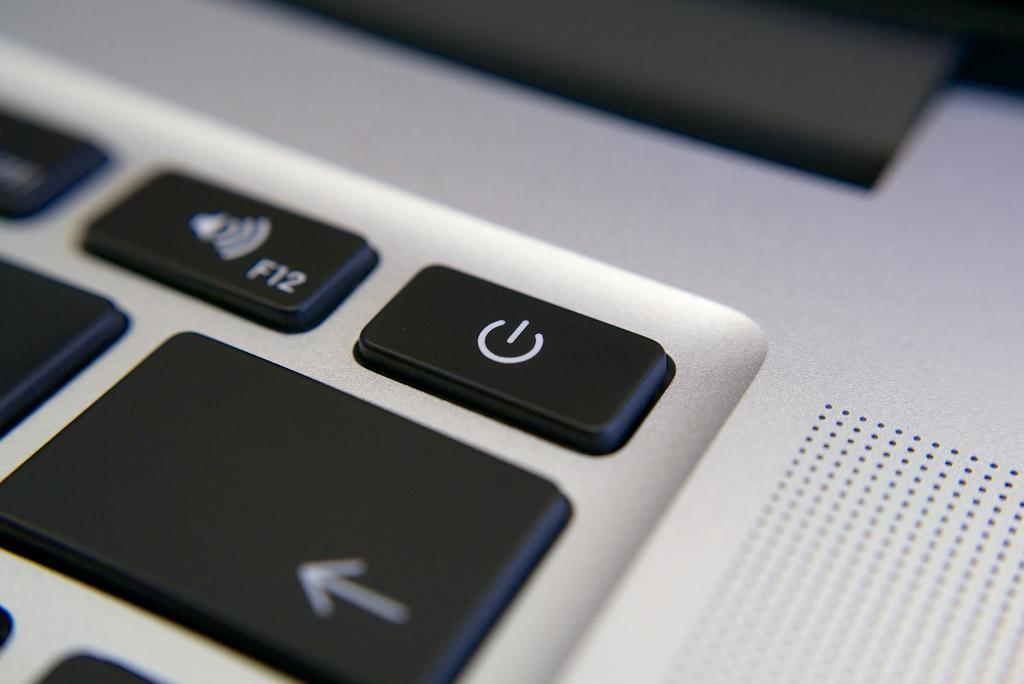<image>
Give a short and clear explanation of the subsequent image. Keyboard key that says F12 on it next to a power symbol. 